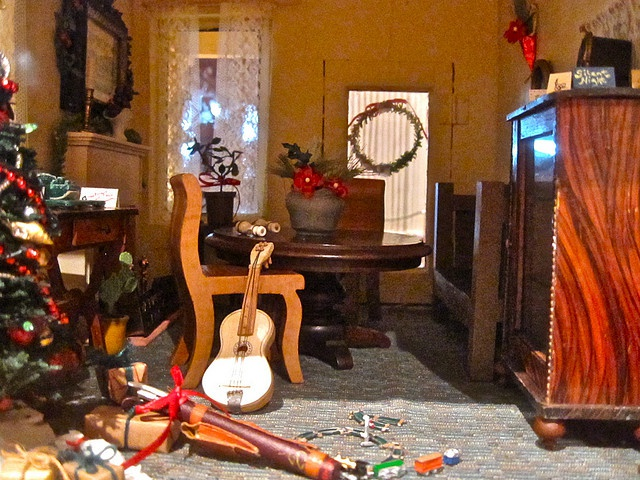Describe the objects in this image and their specific colors. I can see dining table in olive, black, maroon, and tan tones, chair in olive, orange, maroon, brown, and black tones, dining table in olive, black, maroon, and brown tones, chair in olive, maroon, black, brown, and tan tones, and potted plant in olive, black, darkgray, gray, and maroon tones in this image. 